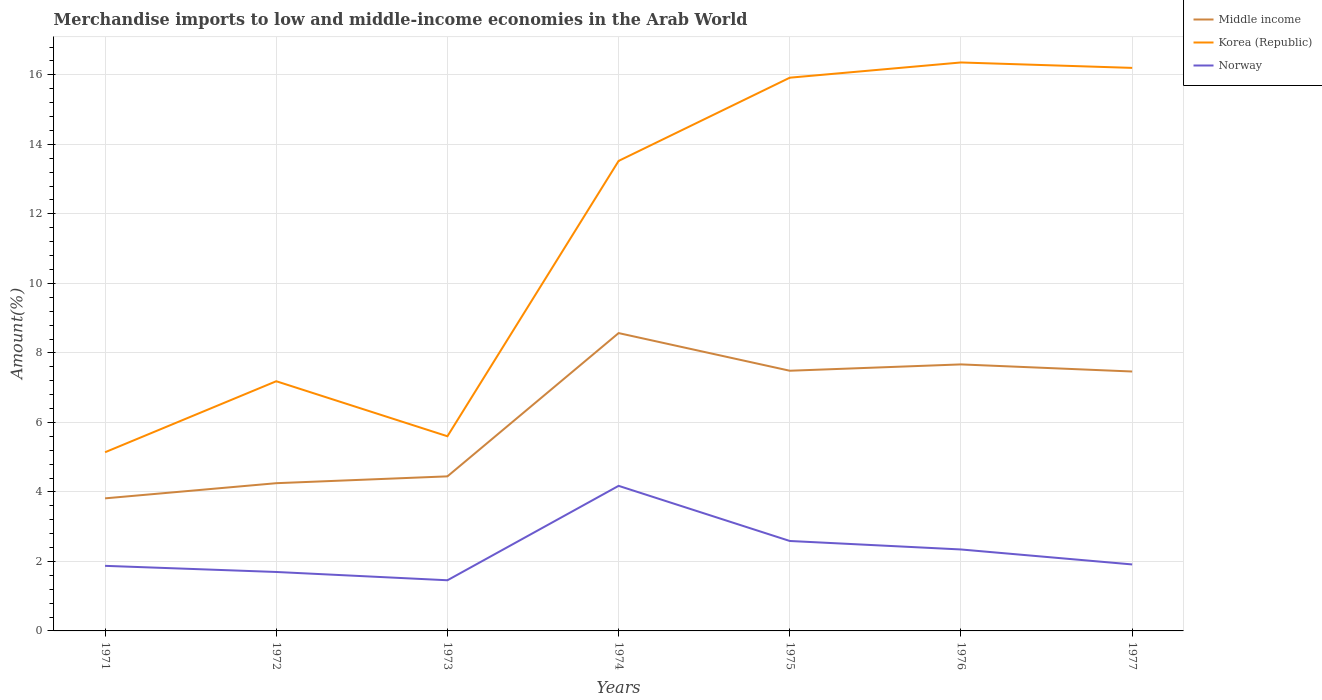How many different coloured lines are there?
Ensure brevity in your answer.  3. Is the number of lines equal to the number of legend labels?
Offer a very short reply. Yes. Across all years, what is the maximum percentage of amount earned from merchandise imports in Norway?
Provide a short and direct response. 1.46. What is the total percentage of amount earned from merchandise imports in Korea (Republic) in the graph?
Offer a very short reply. -8.38. What is the difference between the highest and the second highest percentage of amount earned from merchandise imports in Korea (Republic)?
Ensure brevity in your answer.  11.22. What is the difference between the highest and the lowest percentage of amount earned from merchandise imports in Korea (Republic)?
Your response must be concise. 4. What is the difference between two consecutive major ticks on the Y-axis?
Keep it short and to the point. 2. Are the values on the major ticks of Y-axis written in scientific E-notation?
Your answer should be compact. No. Does the graph contain any zero values?
Make the answer very short. No. Does the graph contain grids?
Keep it short and to the point. Yes. What is the title of the graph?
Your response must be concise. Merchandise imports to low and middle-income economies in the Arab World. What is the label or title of the X-axis?
Keep it short and to the point. Years. What is the label or title of the Y-axis?
Ensure brevity in your answer.  Amount(%). What is the Amount(%) of Middle income in 1971?
Your response must be concise. 3.81. What is the Amount(%) of Korea (Republic) in 1971?
Provide a short and direct response. 5.14. What is the Amount(%) in Norway in 1971?
Ensure brevity in your answer.  1.87. What is the Amount(%) in Middle income in 1972?
Offer a terse response. 4.25. What is the Amount(%) in Korea (Republic) in 1972?
Keep it short and to the point. 7.18. What is the Amount(%) in Norway in 1972?
Give a very brief answer. 1.7. What is the Amount(%) in Middle income in 1973?
Your response must be concise. 4.45. What is the Amount(%) in Korea (Republic) in 1973?
Give a very brief answer. 5.6. What is the Amount(%) of Norway in 1973?
Your answer should be compact. 1.46. What is the Amount(%) in Middle income in 1974?
Keep it short and to the point. 8.57. What is the Amount(%) of Korea (Republic) in 1974?
Offer a very short reply. 13.52. What is the Amount(%) in Norway in 1974?
Your answer should be very brief. 4.17. What is the Amount(%) of Middle income in 1975?
Keep it short and to the point. 7.49. What is the Amount(%) in Korea (Republic) in 1975?
Your answer should be very brief. 15.92. What is the Amount(%) in Norway in 1975?
Provide a succinct answer. 2.59. What is the Amount(%) in Middle income in 1976?
Provide a succinct answer. 7.67. What is the Amount(%) in Korea (Republic) in 1976?
Your answer should be very brief. 16.36. What is the Amount(%) in Norway in 1976?
Your answer should be very brief. 2.34. What is the Amount(%) of Middle income in 1977?
Ensure brevity in your answer.  7.46. What is the Amount(%) of Korea (Republic) in 1977?
Give a very brief answer. 16.2. What is the Amount(%) of Norway in 1977?
Make the answer very short. 1.91. Across all years, what is the maximum Amount(%) in Middle income?
Your answer should be compact. 8.57. Across all years, what is the maximum Amount(%) in Korea (Republic)?
Your response must be concise. 16.36. Across all years, what is the maximum Amount(%) in Norway?
Your answer should be very brief. 4.17. Across all years, what is the minimum Amount(%) of Middle income?
Ensure brevity in your answer.  3.81. Across all years, what is the minimum Amount(%) of Korea (Republic)?
Your response must be concise. 5.14. Across all years, what is the minimum Amount(%) of Norway?
Your response must be concise. 1.46. What is the total Amount(%) in Middle income in the graph?
Provide a short and direct response. 43.7. What is the total Amount(%) of Korea (Republic) in the graph?
Keep it short and to the point. 79.93. What is the total Amount(%) in Norway in the graph?
Give a very brief answer. 16.05. What is the difference between the Amount(%) in Middle income in 1971 and that in 1972?
Ensure brevity in your answer.  -0.44. What is the difference between the Amount(%) in Korea (Republic) in 1971 and that in 1972?
Ensure brevity in your answer.  -2.04. What is the difference between the Amount(%) of Norway in 1971 and that in 1972?
Make the answer very short. 0.18. What is the difference between the Amount(%) in Middle income in 1971 and that in 1973?
Offer a terse response. -0.63. What is the difference between the Amount(%) of Korea (Republic) in 1971 and that in 1973?
Your response must be concise. -0.46. What is the difference between the Amount(%) of Norway in 1971 and that in 1973?
Your response must be concise. 0.41. What is the difference between the Amount(%) in Middle income in 1971 and that in 1974?
Your answer should be very brief. -4.76. What is the difference between the Amount(%) of Korea (Republic) in 1971 and that in 1974?
Provide a short and direct response. -8.38. What is the difference between the Amount(%) of Norway in 1971 and that in 1974?
Make the answer very short. -2.3. What is the difference between the Amount(%) in Middle income in 1971 and that in 1975?
Offer a very short reply. -3.67. What is the difference between the Amount(%) of Korea (Republic) in 1971 and that in 1975?
Provide a succinct answer. -10.78. What is the difference between the Amount(%) of Norway in 1971 and that in 1975?
Your answer should be compact. -0.72. What is the difference between the Amount(%) in Middle income in 1971 and that in 1976?
Offer a very short reply. -3.85. What is the difference between the Amount(%) of Korea (Republic) in 1971 and that in 1976?
Provide a short and direct response. -11.22. What is the difference between the Amount(%) of Norway in 1971 and that in 1976?
Your answer should be very brief. -0.47. What is the difference between the Amount(%) in Middle income in 1971 and that in 1977?
Your response must be concise. -3.65. What is the difference between the Amount(%) of Korea (Republic) in 1971 and that in 1977?
Ensure brevity in your answer.  -11.06. What is the difference between the Amount(%) of Norway in 1971 and that in 1977?
Offer a terse response. -0.04. What is the difference between the Amount(%) in Middle income in 1972 and that in 1973?
Your answer should be compact. -0.2. What is the difference between the Amount(%) in Korea (Republic) in 1972 and that in 1973?
Make the answer very short. 1.58. What is the difference between the Amount(%) in Norway in 1972 and that in 1973?
Offer a terse response. 0.24. What is the difference between the Amount(%) of Middle income in 1972 and that in 1974?
Provide a succinct answer. -4.32. What is the difference between the Amount(%) in Korea (Republic) in 1972 and that in 1974?
Make the answer very short. -6.34. What is the difference between the Amount(%) of Norway in 1972 and that in 1974?
Offer a terse response. -2.48. What is the difference between the Amount(%) in Middle income in 1972 and that in 1975?
Your response must be concise. -3.24. What is the difference between the Amount(%) of Korea (Republic) in 1972 and that in 1975?
Make the answer very short. -8.73. What is the difference between the Amount(%) of Norway in 1972 and that in 1975?
Give a very brief answer. -0.89. What is the difference between the Amount(%) in Middle income in 1972 and that in 1976?
Your response must be concise. -3.42. What is the difference between the Amount(%) of Korea (Republic) in 1972 and that in 1976?
Make the answer very short. -9.17. What is the difference between the Amount(%) in Norway in 1972 and that in 1976?
Your answer should be very brief. -0.65. What is the difference between the Amount(%) of Middle income in 1972 and that in 1977?
Provide a short and direct response. -3.21. What is the difference between the Amount(%) in Korea (Republic) in 1972 and that in 1977?
Provide a short and direct response. -9.02. What is the difference between the Amount(%) in Norway in 1972 and that in 1977?
Make the answer very short. -0.22. What is the difference between the Amount(%) in Middle income in 1973 and that in 1974?
Keep it short and to the point. -4.12. What is the difference between the Amount(%) in Korea (Republic) in 1973 and that in 1974?
Provide a succinct answer. -7.92. What is the difference between the Amount(%) of Norway in 1973 and that in 1974?
Your answer should be very brief. -2.72. What is the difference between the Amount(%) in Middle income in 1973 and that in 1975?
Your answer should be very brief. -3.04. What is the difference between the Amount(%) in Korea (Republic) in 1973 and that in 1975?
Ensure brevity in your answer.  -10.32. What is the difference between the Amount(%) in Norway in 1973 and that in 1975?
Provide a succinct answer. -1.13. What is the difference between the Amount(%) in Middle income in 1973 and that in 1976?
Your answer should be compact. -3.22. What is the difference between the Amount(%) in Korea (Republic) in 1973 and that in 1976?
Keep it short and to the point. -10.76. What is the difference between the Amount(%) of Norway in 1973 and that in 1976?
Provide a short and direct response. -0.89. What is the difference between the Amount(%) in Middle income in 1973 and that in 1977?
Provide a succinct answer. -3.02. What is the difference between the Amount(%) of Korea (Republic) in 1973 and that in 1977?
Keep it short and to the point. -10.6. What is the difference between the Amount(%) of Norway in 1973 and that in 1977?
Provide a short and direct response. -0.46. What is the difference between the Amount(%) of Middle income in 1974 and that in 1975?
Your response must be concise. 1.08. What is the difference between the Amount(%) of Korea (Republic) in 1974 and that in 1975?
Keep it short and to the point. -2.4. What is the difference between the Amount(%) in Norway in 1974 and that in 1975?
Provide a succinct answer. 1.59. What is the difference between the Amount(%) of Middle income in 1974 and that in 1976?
Provide a short and direct response. 0.9. What is the difference between the Amount(%) of Korea (Republic) in 1974 and that in 1976?
Offer a very short reply. -2.83. What is the difference between the Amount(%) in Norway in 1974 and that in 1976?
Provide a succinct answer. 1.83. What is the difference between the Amount(%) in Middle income in 1974 and that in 1977?
Keep it short and to the point. 1.11. What is the difference between the Amount(%) in Korea (Republic) in 1974 and that in 1977?
Provide a succinct answer. -2.68. What is the difference between the Amount(%) in Norway in 1974 and that in 1977?
Give a very brief answer. 2.26. What is the difference between the Amount(%) of Middle income in 1975 and that in 1976?
Your answer should be compact. -0.18. What is the difference between the Amount(%) of Korea (Republic) in 1975 and that in 1976?
Provide a succinct answer. -0.44. What is the difference between the Amount(%) in Norway in 1975 and that in 1976?
Make the answer very short. 0.24. What is the difference between the Amount(%) of Middle income in 1975 and that in 1977?
Give a very brief answer. 0.02. What is the difference between the Amount(%) of Korea (Republic) in 1975 and that in 1977?
Provide a short and direct response. -0.28. What is the difference between the Amount(%) in Norway in 1975 and that in 1977?
Ensure brevity in your answer.  0.67. What is the difference between the Amount(%) of Middle income in 1976 and that in 1977?
Keep it short and to the point. 0.2. What is the difference between the Amount(%) in Korea (Republic) in 1976 and that in 1977?
Your answer should be compact. 0.16. What is the difference between the Amount(%) in Norway in 1976 and that in 1977?
Offer a very short reply. 0.43. What is the difference between the Amount(%) in Middle income in 1971 and the Amount(%) in Korea (Republic) in 1972?
Offer a very short reply. -3.37. What is the difference between the Amount(%) in Middle income in 1971 and the Amount(%) in Norway in 1972?
Provide a short and direct response. 2.12. What is the difference between the Amount(%) of Korea (Republic) in 1971 and the Amount(%) of Norway in 1972?
Offer a terse response. 3.45. What is the difference between the Amount(%) in Middle income in 1971 and the Amount(%) in Korea (Republic) in 1973?
Provide a succinct answer. -1.79. What is the difference between the Amount(%) in Middle income in 1971 and the Amount(%) in Norway in 1973?
Provide a short and direct response. 2.36. What is the difference between the Amount(%) in Korea (Republic) in 1971 and the Amount(%) in Norway in 1973?
Ensure brevity in your answer.  3.68. What is the difference between the Amount(%) of Middle income in 1971 and the Amount(%) of Korea (Republic) in 1974?
Make the answer very short. -9.71. What is the difference between the Amount(%) in Middle income in 1971 and the Amount(%) in Norway in 1974?
Keep it short and to the point. -0.36. What is the difference between the Amount(%) of Korea (Republic) in 1971 and the Amount(%) of Norway in 1974?
Your response must be concise. 0.97. What is the difference between the Amount(%) in Middle income in 1971 and the Amount(%) in Korea (Republic) in 1975?
Provide a short and direct response. -12.1. What is the difference between the Amount(%) in Middle income in 1971 and the Amount(%) in Norway in 1975?
Provide a short and direct response. 1.23. What is the difference between the Amount(%) in Korea (Republic) in 1971 and the Amount(%) in Norway in 1975?
Give a very brief answer. 2.55. What is the difference between the Amount(%) of Middle income in 1971 and the Amount(%) of Korea (Republic) in 1976?
Your answer should be compact. -12.54. What is the difference between the Amount(%) in Middle income in 1971 and the Amount(%) in Norway in 1976?
Give a very brief answer. 1.47. What is the difference between the Amount(%) of Korea (Republic) in 1971 and the Amount(%) of Norway in 1976?
Provide a short and direct response. 2.8. What is the difference between the Amount(%) of Middle income in 1971 and the Amount(%) of Korea (Republic) in 1977?
Make the answer very short. -12.39. What is the difference between the Amount(%) in Middle income in 1971 and the Amount(%) in Norway in 1977?
Your answer should be compact. 1.9. What is the difference between the Amount(%) in Korea (Republic) in 1971 and the Amount(%) in Norway in 1977?
Make the answer very short. 3.23. What is the difference between the Amount(%) in Middle income in 1972 and the Amount(%) in Korea (Republic) in 1973?
Give a very brief answer. -1.35. What is the difference between the Amount(%) of Middle income in 1972 and the Amount(%) of Norway in 1973?
Offer a terse response. 2.79. What is the difference between the Amount(%) of Korea (Republic) in 1972 and the Amount(%) of Norway in 1973?
Offer a terse response. 5.73. What is the difference between the Amount(%) of Middle income in 1972 and the Amount(%) of Korea (Republic) in 1974?
Provide a short and direct response. -9.27. What is the difference between the Amount(%) of Middle income in 1972 and the Amount(%) of Norway in 1974?
Make the answer very short. 0.08. What is the difference between the Amount(%) in Korea (Republic) in 1972 and the Amount(%) in Norway in 1974?
Your response must be concise. 3.01. What is the difference between the Amount(%) of Middle income in 1972 and the Amount(%) of Korea (Republic) in 1975?
Your answer should be compact. -11.67. What is the difference between the Amount(%) of Middle income in 1972 and the Amount(%) of Norway in 1975?
Offer a very short reply. 1.66. What is the difference between the Amount(%) of Korea (Republic) in 1972 and the Amount(%) of Norway in 1975?
Provide a succinct answer. 4.6. What is the difference between the Amount(%) of Middle income in 1972 and the Amount(%) of Korea (Republic) in 1976?
Give a very brief answer. -12.11. What is the difference between the Amount(%) of Middle income in 1972 and the Amount(%) of Norway in 1976?
Your answer should be very brief. 1.91. What is the difference between the Amount(%) of Korea (Republic) in 1972 and the Amount(%) of Norway in 1976?
Offer a very short reply. 4.84. What is the difference between the Amount(%) of Middle income in 1972 and the Amount(%) of Korea (Republic) in 1977?
Offer a terse response. -11.95. What is the difference between the Amount(%) in Middle income in 1972 and the Amount(%) in Norway in 1977?
Your answer should be compact. 2.34. What is the difference between the Amount(%) in Korea (Republic) in 1972 and the Amount(%) in Norway in 1977?
Ensure brevity in your answer.  5.27. What is the difference between the Amount(%) of Middle income in 1973 and the Amount(%) of Korea (Republic) in 1974?
Your answer should be very brief. -9.08. What is the difference between the Amount(%) in Middle income in 1973 and the Amount(%) in Norway in 1974?
Your answer should be compact. 0.27. What is the difference between the Amount(%) in Korea (Republic) in 1973 and the Amount(%) in Norway in 1974?
Provide a succinct answer. 1.43. What is the difference between the Amount(%) of Middle income in 1973 and the Amount(%) of Korea (Republic) in 1975?
Give a very brief answer. -11.47. What is the difference between the Amount(%) of Middle income in 1973 and the Amount(%) of Norway in 1975?
Offer a very short reply. 1.86. What is the difference between the Amount(%) in Korea (Republic) in 1973 and the Amount(%) in Norway in 1975?
Give a very brief answer. 3.01. What is the difference between the Amount(%) in Middle income in 1973 and the Amount(%) in Korea (Republic) in 1976?
Ensure brevity in your answer.  -11.91. What is the difference between the Amount(%) in Middle income in 1973 and the Amount(%) in Norway in 1976?
Your answer should be compact. 2.1. What is the difference between the Amount(%) of Korea (Republic) in 1973 and the Amount(%) of Norway in 1976?
Your answer should be very brief. 3.26. What is the difference between the Amount(%) in Middle income in 1973 and the Amount(%) in Korea (Republic) in 1977?
Offer a very short reply. -11.75. What is the difference between the Amount(%) in Middle income in 1973 and the Amount(%) in Norway in 1977?
Keep it short and to the point. 2.53. What is the difference between the Amount(%) in Korea (Republic) in 1973 and the Amount(%) in Norway in 1977?
Your answer should be compact. 3.69. What is the difference between the Amount(%) in Middle income in 1974 and the Amount(%) in Korea (Republic) in 1975?
Provide a short and direct response. -7.35. What is the difference between the Amount(%) of Middle income in 1974 and the Amount(%) of Norway in 1975?
Offer a terse response. 5.98. What is the difference between the Amount(%) in Korea (Republic) in 1974 and the Amount(%) in Norway in 1975?
Make the answer very short. 10.94. What is the difference between the Amount(%) in Middle income in 1974 and the Amount(%) in Korea (Republic) in 1976?
Your answer should be very brief. -7.79. What is the difference between the Amount(%) of Middle income in 1974 and the Amount(%) of Norway in 1976?
Your response must be concise. 6.23. What is the difference between the Amount(%) of Korea (Republic) in 1974 and the Amount(%) of Norway in 1976?
Provide a short and direct response. 11.18. What is the difference between the Amount(%) in Middle income in 1974 and the Amount(%) in Korea (Republic) in 1977?
Your answer should be very brief. -7.63. What is the difference between the Amount(%) of Middle income in 1974 and the Amount(%) of Norway in 1977?
Provide a short and direct response. 6.66. What is the difference between the Amount(%) of Korea (Republic) in 1974 and the Amount(%) of Norway in 1977?
Offer a very short reply. 11.61. What is the difference between the Amount(%) of Middle income in 1975 and the Amount(%) of Korea (Republic) in 1976?
Your answer should be very brief. -8.87. What is the difference between the Amount(%) of Middle income in 1975 and the Amount(%) of Norway in 1976?
Offer a very short reply. 5.14. What is the difference between the Amount(%) of Korea (Republic) in 1975 and the Amount(%) of Norway in 1976?
Your response must be concise. 13.58. What is the difference between the Amount(%) of Middle income in 1975 and the Amount(%) of Korea (Republic) in 1977?
Your response must be concise. -8.71. What is the difference between the Amount(%) in Middle income in 1975 and the Amount(%) in Norway in 1977?
Make the answer very short. 5.57. What is the difference between the Amount(%) of Korea (Republic) in 1975 and the Amount(%) of Norway in 1977?
Give a very brief answer. 14.01. What is the difference between the Amount(%) of Middle income in 1976 and the Amount(%) of Korea (Republic) in 1977?
Offer a very short reply. -8.53. What is the difference between the Amount(%) of Middle income in 1976 and the Amount(%) of Norway in 1977?
Your response must be concise. 5.76. What is the difference between the Amount(%) of Korea (Republic) in 1976 and the Amount(%) of Norway in 1977?
Give a very brief answer. 14.44. What is the average Amount(%) in Middle income per year?
Give a very brief answer. 6.24. What is the average Amount(%) in Korea (Republic) per year?
Offer a very short reply. 11.42. What is the average Amount(%) in Norway per year?
Offer a terse response. 2.29. In the year 1971, what is the difference between the Amount(%) of Middle income and Amount(%) of Korea (Republic)?
Keep it short and to the point. -1.33. In the year 1971, what is the difference between the Amount(%) of Middle income and Amount(%) of Norway?
Your response must be concise. 1.94. In the year 1971, what is the difference between the Amount(%) in Korea (Republic) and Amount(%) in Norway?
Keep it short and to the point. 3.27. In the year 1972, what is the difference between the Amount(%) in Middle income and Amount(%) in Korea (Republic)?
Your answer should be compact. -2.93. In the year 1972, what is the difference between the Amount(%) in Middle income and Amount(%) in Norway?
Your answer should be very brief. 2.55. In the year 1972, what is the difference between the Amount(%) in Korea (Republic) and Amount(%) in Norway?
Keep it short and to the point. 5.49. In the year 1973, what is the difference between the Amount(%) in Middle income and Amount(%) in Korea (Republic)?
Make the answer very short. -1.15. In the year 1973, what is the difference between the Amount(%) in Middle income and Amount(%) in Norway?
Offer a terse response. 2.99. In the year 1973, what is the difference between the Amount(%) in Korea (Republic) and Amount(%) in Norway?
Your answer should be compact. 4.14. In the year 1974, what is the difference between the Amount(%) in Middle income and Amount(%) in Korea (Republic)?
Give a very brief answer. -4.95. In the year 1974, what is the difference between the Amount(%) of Middle income and Amount(%) of Norway?
Your response must be concise. 4.4. In the year 1974, what is the difference between the Amount(%) of Korea (Republic) and Amount(%) of Norway?
Make the answer very short. 9.35. In the year 1975, what is the difference between the Amount(%) of Middle income and Amount(%) of Korea (Republic)?
Provide a succinct answer. -8.43. In the year 1975, what is the difference between the Amount(%) in Middle income and Amount(%) in Norway?
Provide a short and direct response. 4.9. In the year 1975, what is the difference between the Amount(%) of Korea (Republic) and Amount(%) of Norway?
Offer a very short reply. 13.33. In the year 1976, what is the difference between the Amount(%) in Middle income and Amount(%) in Korea (Republic)?
Keep it short and to the point. -8.69. In the year 1976, what is the difference between the Amount(%) of Middle income and Amount(%) of Norway?
Ensure brevity in your answer.  5.33. In the year 1976, what is the difference between the Amount(%) in Korea (Republic) and Amount(%) in Norway?
Make the answer very short. 14.01. In the year 1977, what is the difference between the Amount(%) in Middle income and Amount(%) in Korea (Republic)?
Offer a terse response. -8.74. In the year 1977, what is the difference between the Amount(%) of Middle income and Amount(%) of Norway?
Give a very brief answer. 5.55. In the year 1977, what is the difference between the Amount(%) in Korea (Republic) and Amount(%) in Norway?
Keep it short and to the point. 14.29. What is the ratio of the Amount(%) of Middle income in 1971 to that in 1972?
Offer a terse response. 0.9. What is the ratio of the Amount(%) of Korea (Republic) in 1971 to that in 1972?
Make the answer very short. 0.72. What is the ratio of the Amount(%) of Norway in 1971 to that in 1972?
Offer a terse response. 1.1. What is the ratio of the Amount(%) of Middle income in 1971 to that in 1973?
Provide a short and direct response. 0.86. What is the ratio of the Amount(%) of Korea (Republic) in 1971 to that in 1973?
Make the answer very short. 0.92. What is the ratio of the Amount(%) in Norway in 1971 to that in 1973?
Ensure brevity in your answer.  1.28. What is the ratio of the Amount(%) in Middle income in 1971 to that in 1974?
Keep it short and to the point. 0.45. What is the ratio of the Amount(%) of Korea (Republic) in 1971 to that in 1974?
Provide a succinct answer. 0.38. What is the ratio of the Amount(%) of Norway in 1971 to that in 1974?
Provide a succinct answer. 0.45. What is the ratio of the Amount(%) in Middle income in 1971 to that in 1975?
Offer a very short reply. 0.51. What is the ratio of the Amount(%) in Korea (Republic) in 1971 to that in 1975?
Provide a short and direct response. 0.32. What is the ratio of the Amount(%) of Norway in 1971 to that in 1975?
Keep it short and to the point. 0.72. What is the ratio of the Amount(%) in Middle income in 1971 to that in 1976?
Your answer should be compact. 0.5. What is the ratio of the Amount(%) of Korea (Republic) in 1971 to that in 1976?
Your answer should be compact. 0.31. What is the ratio of the Amount(%) of Norway in 1971 to that in 1976?
Keep it short and to the point. 0.8. What is the ratio of the Amount(%) in Middle income in 1971 to that in 1977?
Make the answer very short. 0.51. What is the ratio of the Amount(%) of Korea (Republic) in 1971 to that in 1977?
Give a very brief answer. 0.32. What is the ratio of the Amount(%) of Norway in 1971 to that in 1977?
Make the answer very short. 0.98. What is the ratio of the Amount(%) of Middle income in 1972 to that in 1973?
Make the answer very short. 0.96. What is the ratio of the Amount(%) of Korea (Republic) in 1972 to that in 1973?
Your answer should be compact. 1.28. What is the ratio of the Amount(%) of Norway in 1972 to that in 1973?
Make the answer very short. 1.16. What is the ratio of the Amount(%) in Middle income in 1972 to that in 1974?
Your answer should be compact. 0.5. What is the ratio of the Amount(%) of Korea (Republic) in 1972 to that in 1974?
Offer a very short reply. 0.53. What is the ratio of the Amount(%) of Norway in 1972 to that in 1974?
Your answer should be very brief. 0.41. What is the ratio of the Amount(%) in Middle income in 1972 to that in 1975?
Your response must be concise. 0.57. What is the ratio of the Amount(%) of Korea (Republic) in 1972 to that in 1975?
Give a very brief answer. 0.45. What is the ratio of the Amount(%) in Norway in 1972 to that in 1975?
Your answer should be very brief. 0.66. What is the ratio of the Amount(%) in Middle income in 1972 to that in 1976?
Provide a short and direct response. 0.55. What is the ratio of the Amount(%) of Korea (Republic) in 1972 to that in 1976?
Your answer should be compact. 0.44. What is the ratio of the Amount(%) of Norway in 1972 to that in 1976?
Make the answer very short. 0.72. What is the ratio of the Amount(%) in Middle income in 1972 to that in 1977?
Offer a very short reply. 0.57. What is the ratio of the Amount(%) in Korea (Republic) in 1972 to that in 1977?
Your answer should be compact. 0.44. What is the ratio of the Amount(%) of Norway in 1972 to that in 1977?
Your answer should be compact. 0.89. What is the ratio of the Amount(%) of Middle income in 1973 to that in 1974?
Your answer should be compact. 0.52. What is the ratio of the Amount(%) in Korea (Republic) in 1973 to that in 1974?
Your answer should be compact. 0.41. What is the ratio of the Amount(%) in Norway in 1973 to that in 1974?
Make the answer very short. 0.35. What is the ratio of the Amount(%) in Middle income in 1973 to that in 1975?
Provide a succinct answer. 0.59. What is the ratio of the Amount(%) of Korea (Republic) in 1973 to that in 1975?
Your answer should be very brief. 0.35. What is the ratio of the Amount(%) of Norway in 1973 to that in 1975?
Your answer should be compact. 0.56. What is the ratio of the Amount(%) in Middle income in 1973 to that in 1976?
Offer a terse response. 0.58. What is the ratio of the Amount(%) in Korea (Republic) in 1973 to that in 1976?
Your answer should be very brief. 0.34. What is the ratio of the Amount(%) in Norway in 1973 to that in 1976?
Make the answer very short. 0.62. What is the ratio of the Amount(%) in Middle income in 1973 to that in 1977?
Provide a short and direct response. 0.6. What is the ratio of the Amount(%) in Korea (Republic) in 1973 to that in 1977?
Keep it short and to the point. 0.35. What is the ratio of the Amount(%) in Norway in 1973 to that in 1977?
Offer a very short reply. 0.76. What is the ratio of the Amount(%) of Middle income in 1974 to that in 1975?
Your answer should be compact. 1.14. What is the ratio of the Amount(%) of Korea (Republic) in 1974 to that in 1975?
Provide a short and direct response. 0.85. What is the ratio of the Amount(%) in Norway in 1974 to that in 1975?
Offer a very short reply. 1.61. What is the ratio of the Amount(%) of Middle income in 1974 to that in 1976?
Give a very brief answer. 1.12. What is the ratio of the Amount(%) in Korea (Republic) in 1974 to that in 1976?
Provide a short and direct response. 0.83. What is the ratio of the Amount(%) in Norway in 1974 to that in 1976?
Your response must be concise. 1.78. What is the ratio of the Amount(%) in Middle income in 1974 to that in 1977?
Offer a very short reply. 1.15. What is the ratio of the Amount(%) in Korea (Republic) in 1974 to that in 1977?
Your answer should be compact. 0.83. What is the ratio of the Amount(%) in Norway in 1974 to that in 1977?
Provide a short and direct response. 2.18. What is the ratio of the Amount(%) of Middle income in 1975 to that in 1976?
Keep it short and to the point. 0.98. What is the ratio of the Amount(%) of Korea (Republic) in 1975 to that in 1976?
Ensure brevity in your answer.  0.97. What is the ratio of the Amount(%) of Norway in 1975 to that in 1976?
Provide a short and direct response. 1.1. What is the ratio of the Amount(%) of Korea (Republic) in 1975 to that in 1977?
Give a very brief answer. 0.98. What is the ratio of the Amount(%) in Norway in 1975 to that in 1977?
Your response must be concise. 1.35. What is the ratio of the Amount(%) of Middle income in 1976 to that in 1977?
Ensure brevity in your answer.  1.03. What is the ratio of the Amount(%) in Korea (Republic) in 1976 to that in 1977?
Offer a terse response. 1.01. What is the ratio of the Amount(%) of Norway in 1976 to that in 1977?
Provide a succinct answer. 1.23. What is the difference between the highest and the second highest Amount(%) in Middle income?
Ensure brevity in your answer.  0.9. What is the difference between the highest and the second highest Amount(%) of Korea (Republic)?
Make the answer very short. 0.16. What is the difference between the highest and the second highest Amount(%) in Norway?
Ensure brevity in your answer.  1.59. What is the difference between the highest and the lowest Amount(%) of Middle income?
Provide a short and direct response. 4.76. What is the difference between the highest and the lowest Amount(%) of Korea (Republic)?
Your response must be concise. 11.22. What is the difference between the highest and the lowest Amount(%) in Norway?
Your response must be concise. 2.72. 